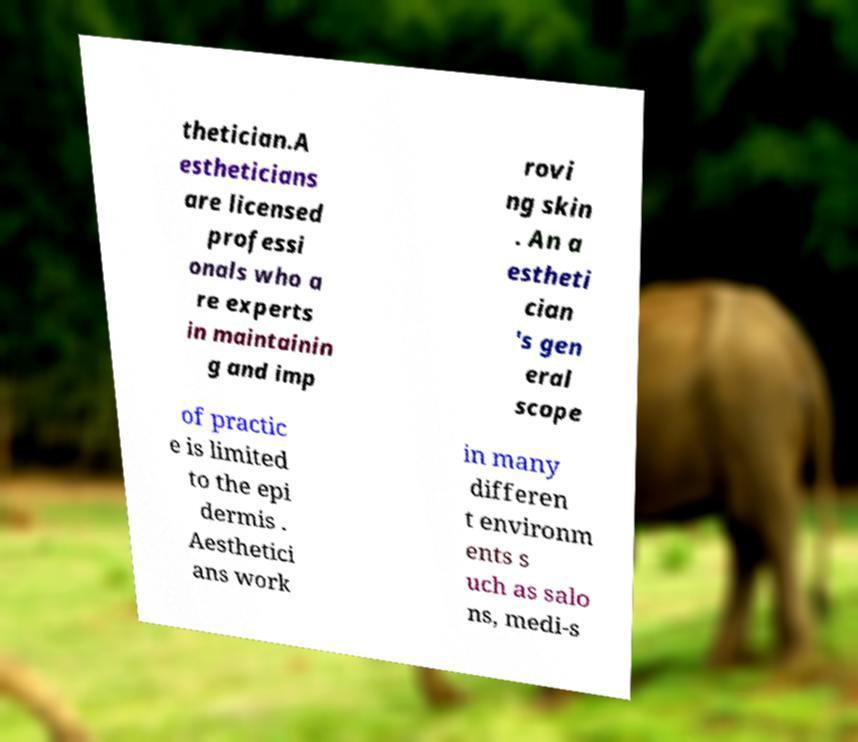What messages or text are displayed in this image? I need them in a readable, typed format. thetician.A estheticians are licensed professi onals who a re experts in maintainin g and imp rovi ng skin . An a estheti cian 's gen eral scope of practic e is limited to the epi dermis . Aesthetici ans work in many differen t environm ents s uch as salo ns, medi-s 